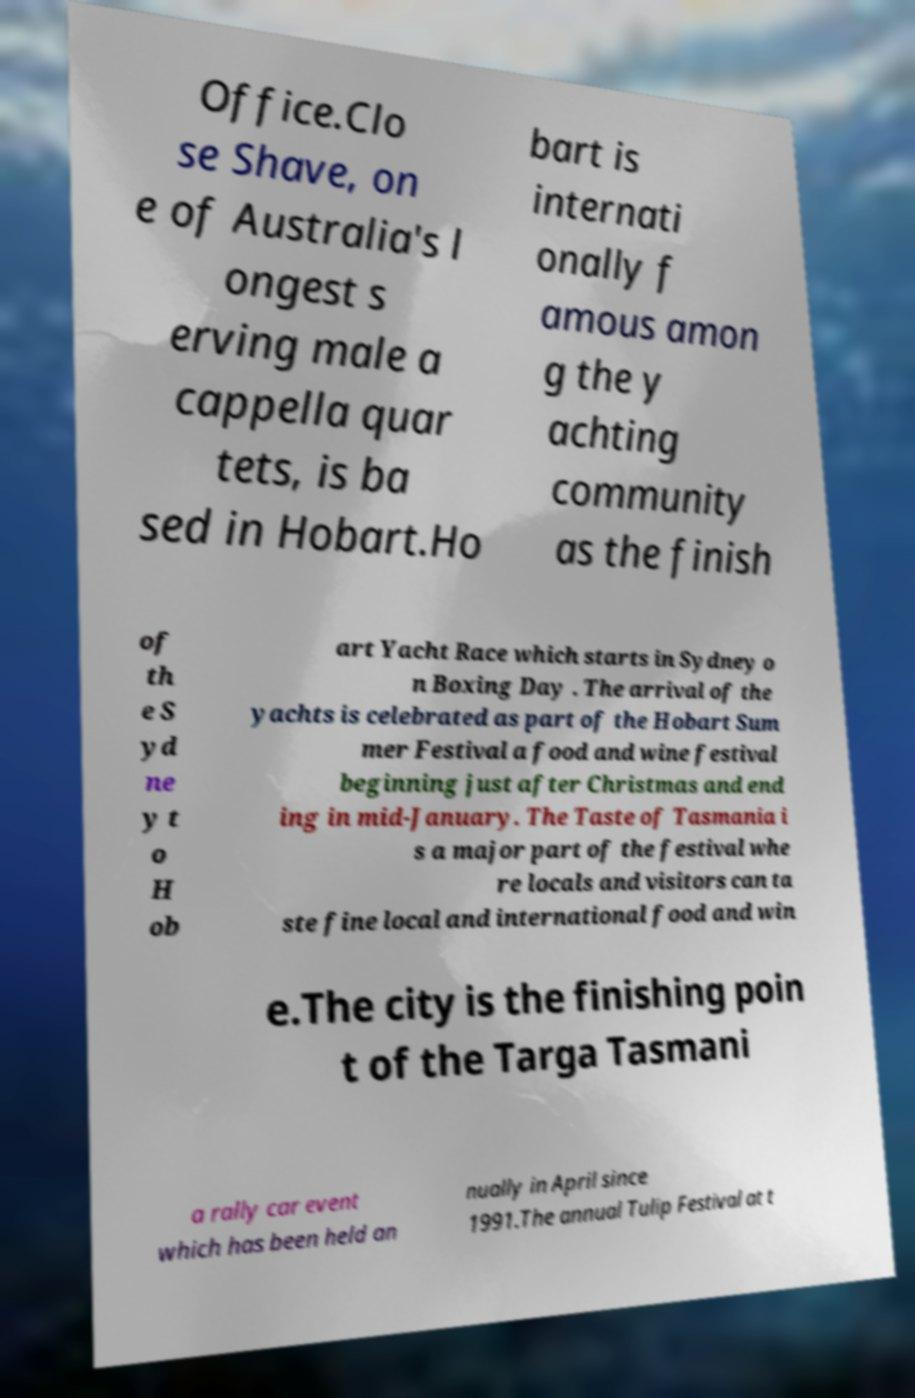Could you assist in decoding the text presented in this image and type it out clearly? Office.Clo se Shave, on e of Australia's l ongest s erving male a cappella quar tets, is ba sed in Hobart.Ho bart is internati onally f amous amon g the y achting community as the finish of th e S yd ne y t o H ob art Yacht Race which starts in Sydney o n Boxing Day . The arrival of the yachts is celebrated as part of the Hobart Sum mer Festival a food and wine festival beginning just after Christmas and end ing in mid-January. The Taste of Tasmania i s a major part of the festival whe re locals and visitors can ta ste fine local and international food and win e.The city is the finishing poin t of the Targa Tasmani a rally car event which has been held an nually in April since 1991.The annual Tulip Festival at t 